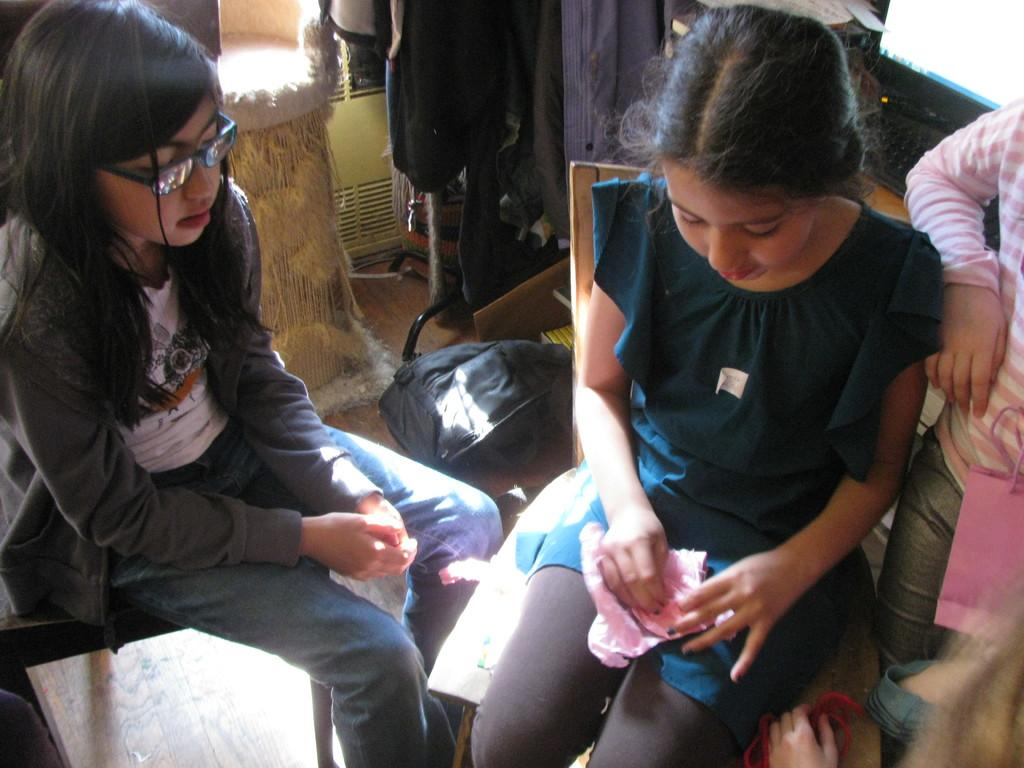Who is present in the image? There are girls in the image. What are the girls doing in the image? Two girls are sitting on chairs. What can be seen in the background of the image? There is a screen and other objects on the floor in the background of the image. What type of salt is being used by the girls in the image? There is no salt present in the image, and the girls are not using any salt. What kind of border is depicted in the image? There is no border depicted in the image; it features girls sitting on chairs and a background with a screen and other objects on the floor. 